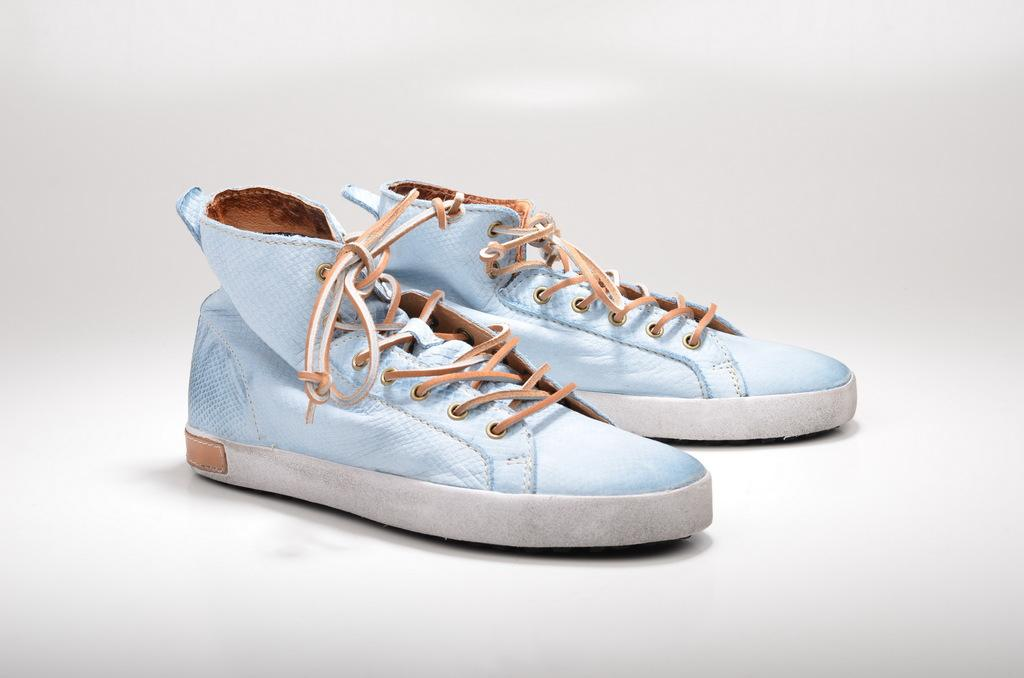What objects are in the image? There are shoes in the image. Where are the shoes located? The shoes are kept on a table. What type of silver sheet is covering the shoes in the image? There is no silver sheet present in the image; the shoes are simply placed on a table. 